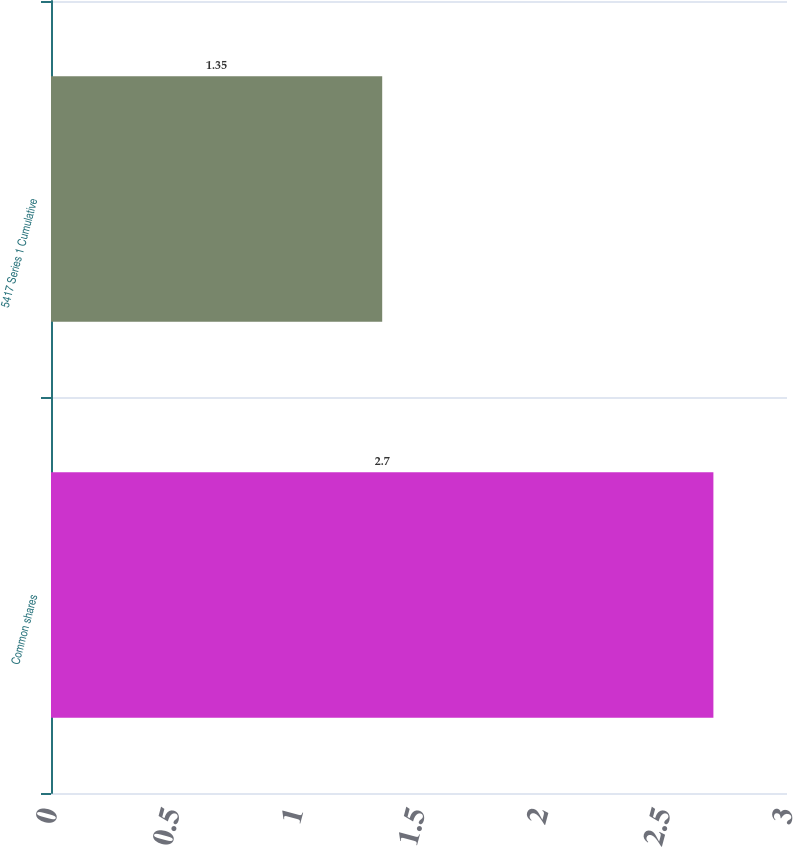Convert chart. <chart><loc_0><loc_0><loc_500><loc_500><bar_chart><fcel>Common shares<fcel>5417 Series 1 Cumulative<nl><fcel>2.7<fcel>1.35<nl></chart> 